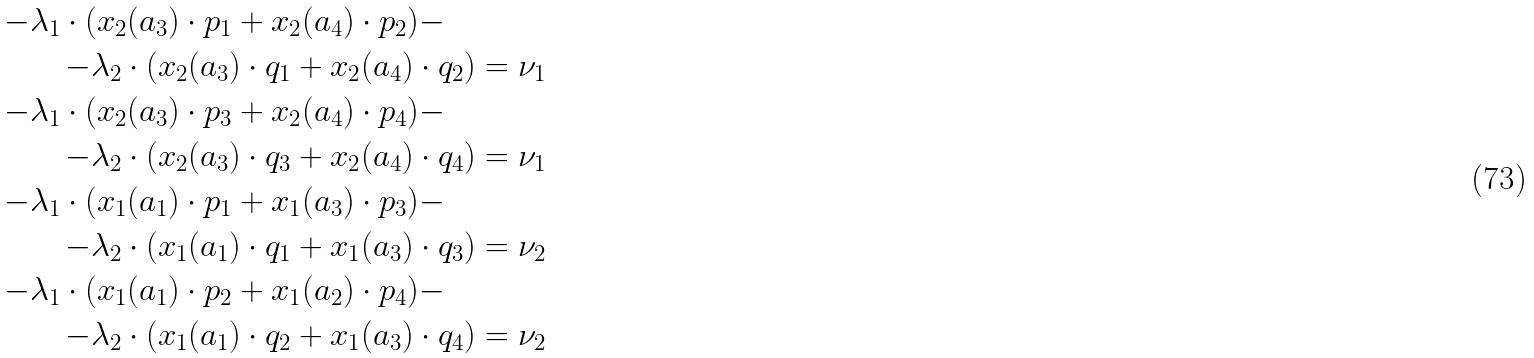Convert formula to latex. <formula><loc_0><loc_0><loc_500><loc_500>- \lambda _ { 1 } \cdot ( x _ { 2 } ( a _ { 3 } ) \cdot p _ { 1 } + x _ { 2 } ( a _ { 4 } ) \cdot p _ { 2 } ) - \quad \\ - \lambda _ { 2 } \cdot ( x _ { 2 } ( a _ { 3 } ) \cdot q _ { 1 } + x _ { 2 } ( a _ { 4 } ) \cdot q _ { 2 } ) & = \nu _ { 1 } \\ - \lambda _ { 1 } \cdot ( x _ { 2 } ( a _ { 3 } ) \cdot p _ { 3 } + x _ { 2 } ( a _ { 4 } ) \cdot p _ { 4 } ) - \quad \\ - \lambda _ { 2 } \cdot ( x _ { 2 } ( a _ { 3 } ) \cdot q _ { 3 } + x _ { 2 } ( a _ { 4 } ) \cdot q _ { 4 } ) & = \nu _ { 1 } \\ - \lambda _ { 1 } \cdot ( x _ { 1 } ( a _ { 1 } ) \cdot p _ { 1 } + x _ { 1 } ( a _ { 3 } ) \cdot p _ { 3 } ) - \quad \\ - \lambda _ { 2 } \cdot ( x _ { 1 } ( a _ { 1 } ) \cdot q _ { 1 } + x _ { 1 } ( a _ { 3 } ) \cdot q _ { 3 } ) & = \nu _ { 2 } \\ - \lambda _ { 1 } \cdot ( x _ { 1 } ( a _ { 1 } ) \cdot p _ { 2 } + x _ { 1 } ( a _ { 2 } ) \cdot p _ { 4 } ) - \quad \\ - \lambda _ { 2 } \cdot ( x _ { 1 } ( a _ { 1 } ) \cdot q _ { 2 } + x _ { 1 } ( a _ { 3 } ) \cdot q _ { 4 } ) & = \nu _ { 2 }</formula> 